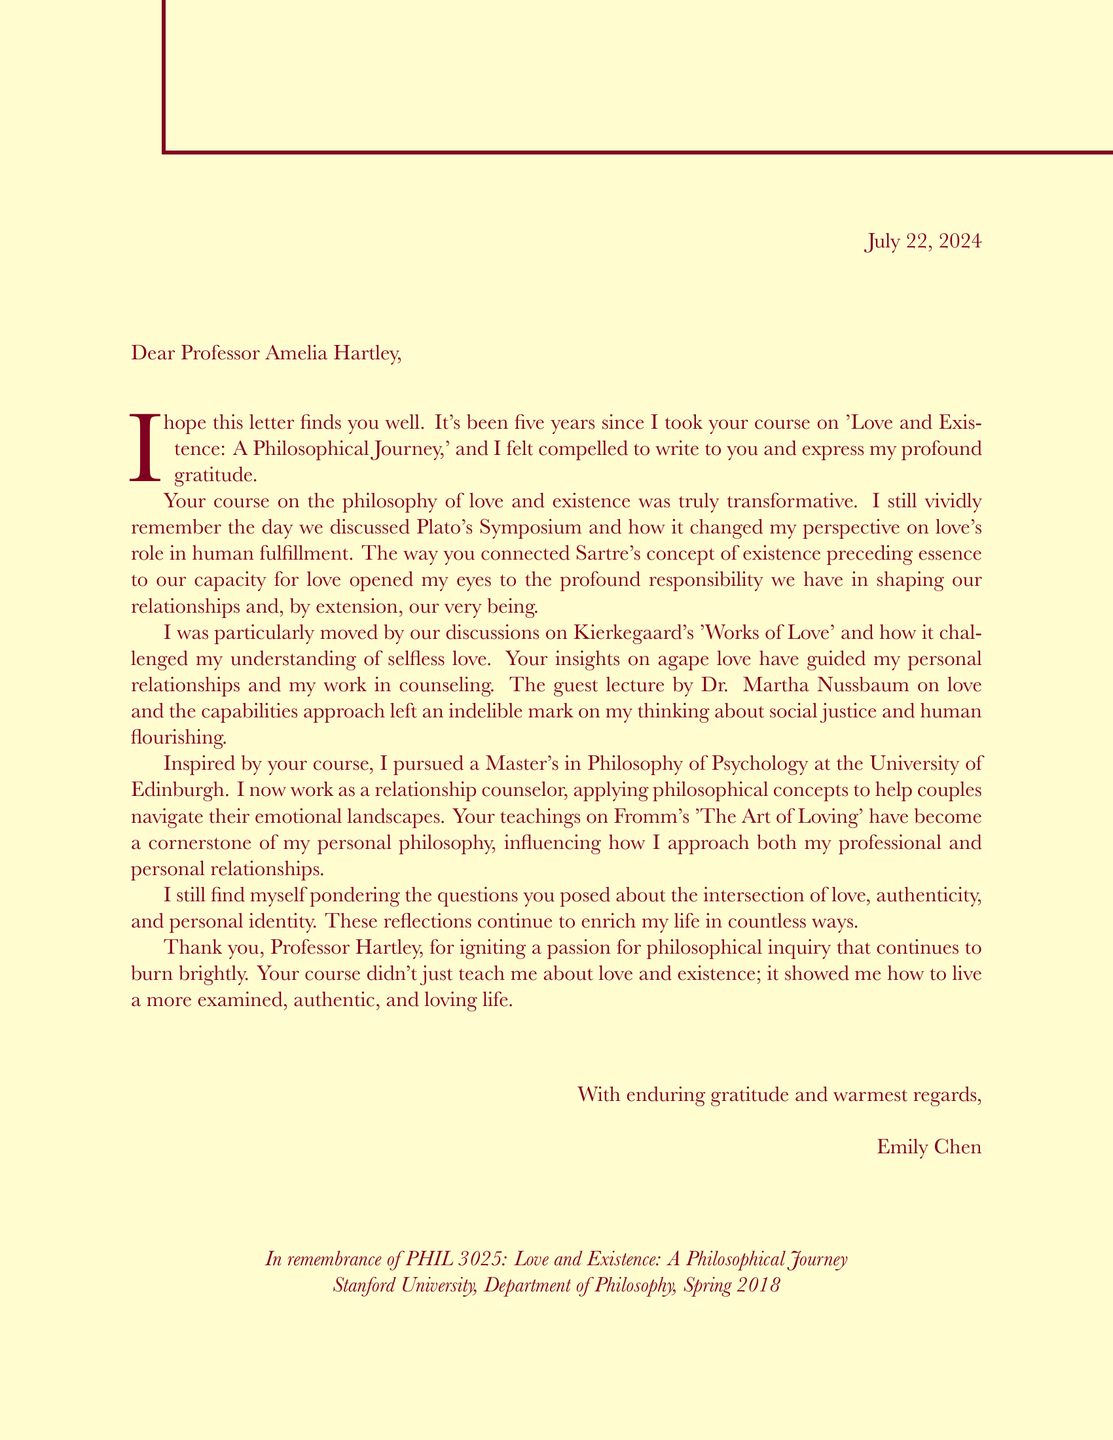What is the name of the professor? The professor's name is mentioned in the salutation of the letter.
Answer: Amelia Hartley What is the course name? The course name is explicitly stated in the opening of the letter.
Answer: Love and Existence: A Philosophical Journey What year was the course taken? The year is indicated as part of the course details provided at the end of the letter.
Answer: Spring 2018 Who was the guest lecturer mentioned? The guest lecturer's name appears in the body of the letter.
Answer: Dr. Martha Nussbaum What university did the student attend for their Master's? The information about the Master's program and the university is provided in the personal impact section.
Answer: University of Edinburgh How long has it been since the student took the course? The time mentioned in the opening of the letter gives this information.
Answer: Five years What did the course inspire the student to pursue? The letter mentions the specific degree pursued by the student after the course.
Answer: Master's in Philosophy of Psychology Which reading had a significant impact on the student? The impactful reading is highlighted in the personal impact section of the letter.
Answer: Fromm's The Art of Loving What philosophical concept fundamentally changed the student's view on love? The concept discussed in the class is referenced in the first paragraph of the letter.
Answer: Existence preceding essence 